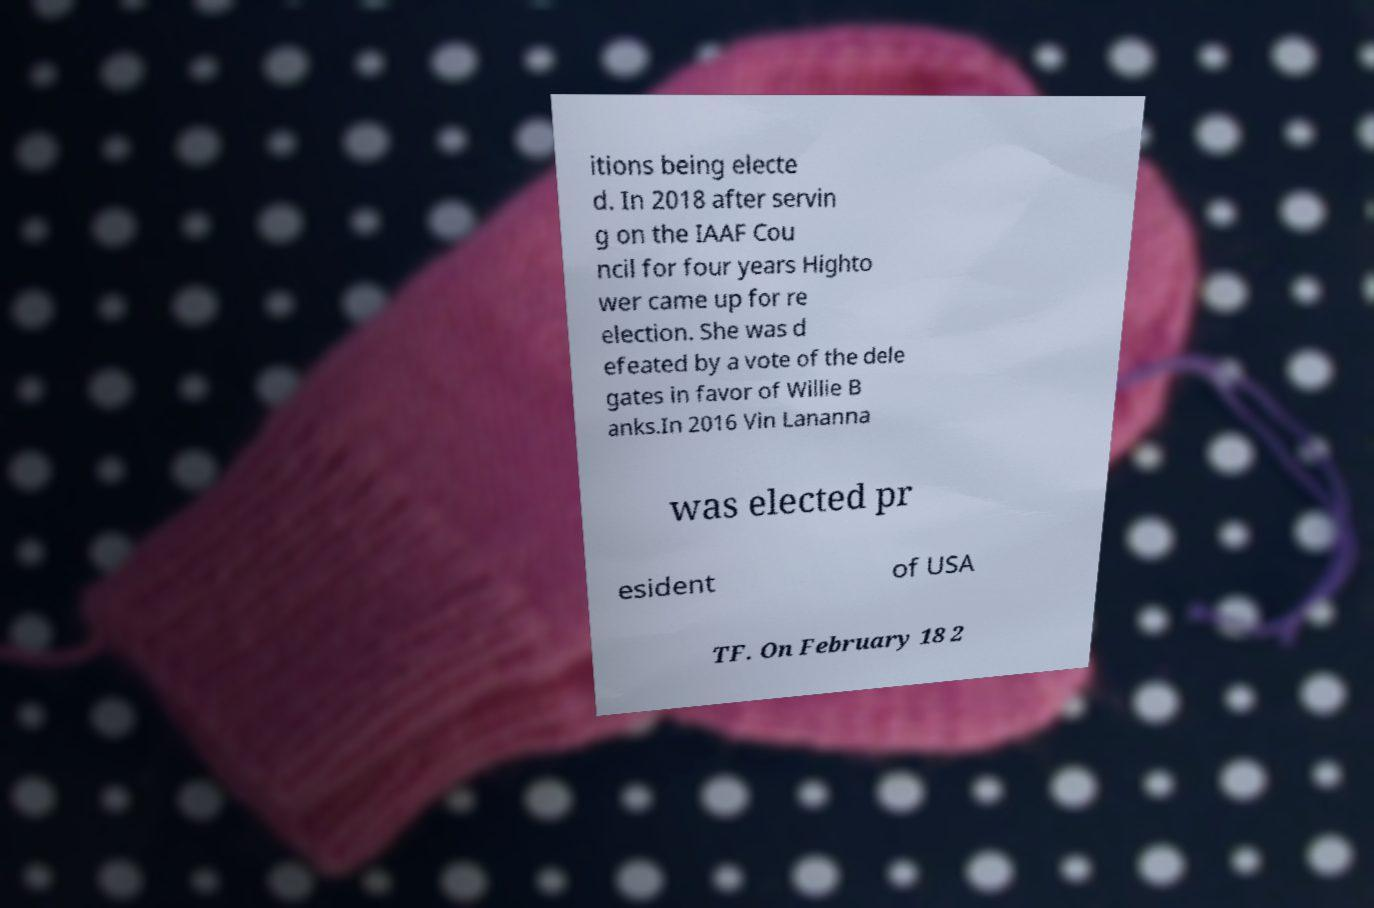There's text embedded in this image that I need extracted. Can you transcribe it verbatim? itions being electe d. In 2018 after servin g on the IAAF Cou ncil for four years Highto wer came up for re election. She was d efeated by a vote of the dele gates in favor of Willie B anks.In 2016 Vin Lananna was elected pr esident of USA TF. On February 18 2 